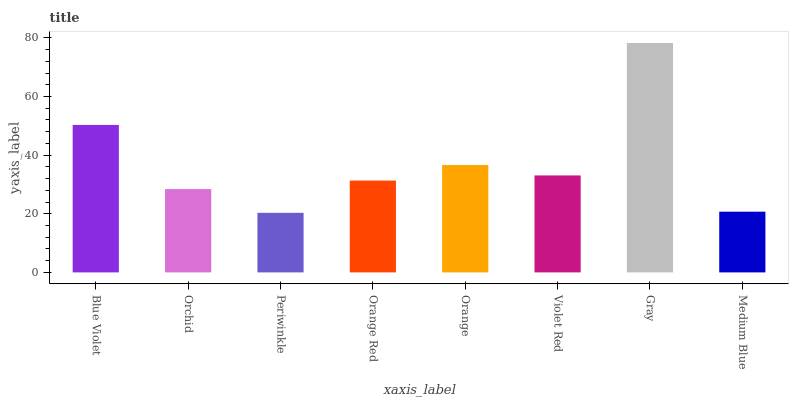Is Periwinkle the minimum?
Answer yes or no. Yes. Is Gray the maximum?
Answer yes or no. Yes. Is Orchid the minimum?
Answer yes or no. No. Is Orchid the maximum?
Answer yes or no. No. Is Blue Violet greater than Orchid?
Answer yes or no. Yes. Is Orchid less than Blue Violet?
Answer yes or no. Yes. Is Orchid greater than Blue Violet?
Answer yes or no. No. Is Blue Violet less than Orchid?
Answer yes or no. No. Is Violet Red the high median?
Answer yes or no. Yes. Is Orange Red the low median?
Answer yes or no. Yes. Is Orange Red the high median?
Answer yes or no. No. Is Gray the low median?
Answer yes or no. No. 